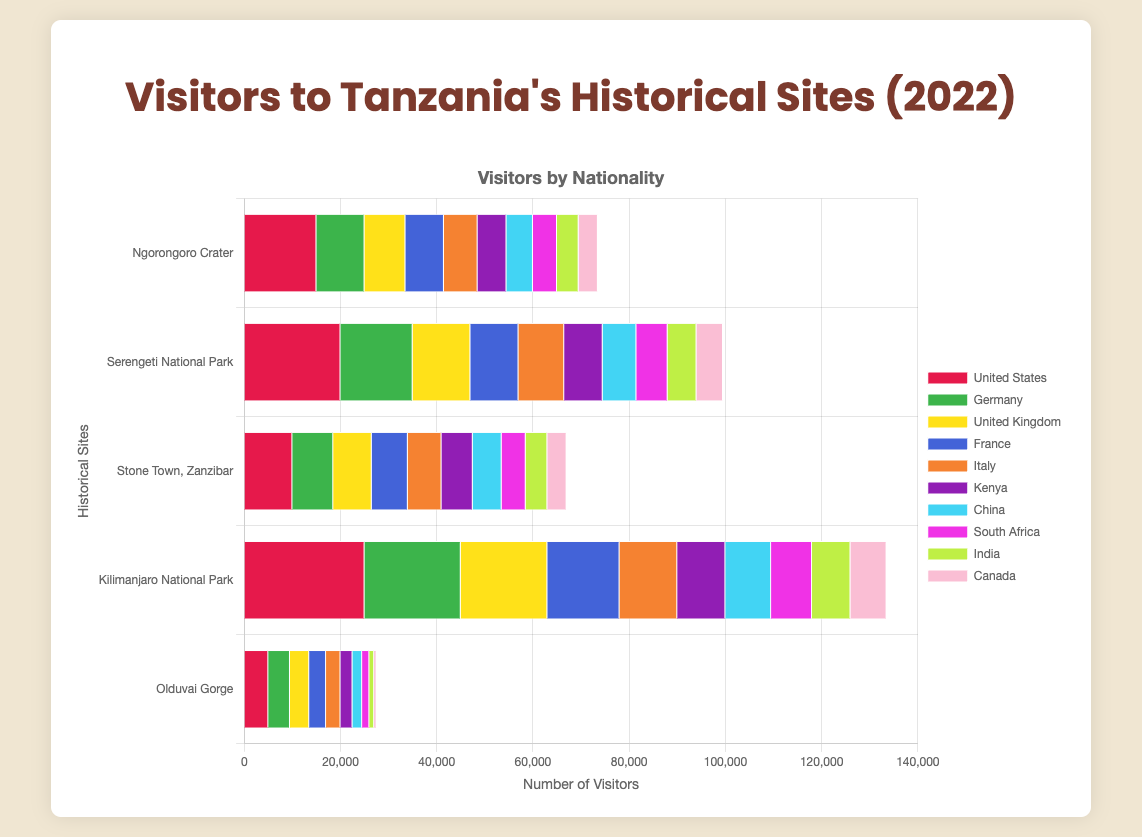Which historical site received the most visitors from the United States? Among all the historical sites, Kilimanjaro National Park has the highest number of visitors from the United States at 25,000.
Answer: Kilimanjaro National Park How many total visitors did Ngorongoro Crater receive from Germany, France, and Italy? Combine the visitors from Germany (10,000), France (8,000), and Italy (7,000) to get a total of 10,000 + 8,000 + 7,000 = 25,000 visitors.
Answer: 25,000 Which site had more visitors from China: Serengeti National Park or Stone Town, Zanzibar? Serengeti National Park had 7,000 visitors from China, while Stone Town, Zanzibar had 6,000 visitors from China. Therefore, Serengeti National Park had more visitors.
Answer: Serengeti National Park What is the difference in the number of visitors from Kenya between Kilimanjaro National Park and Olduvai Gorge? Kilimanjaro National Park had 10,000 visitors from Kenya and Olduvai Gorge had 2,500. The difference is 10,000 - 2,500 = 7,500 visitors.
Answer: 7,500 Which nationality consistently has the least number of visitors across all sites? By examining each site's visitors data, Canada consistently has the least number of visitors across all the sites, with the least being 500 visitors at Olduvai Gorge.
Answer: Canada Between Ngorongoro Crater and Stone Town, Zanzibar, which site had more visitors from the United Kingdom? Ngorongoro Crater had 8,500 visitors from the United Kingdom, whereas Stone Town, Zanzibar had 8,000 visitors from the United Kingdom. Ngorongoro Crater had more visitors.
Answer: Ngorongoro Crater How many visitors in total did Serengeti National Park receive? Add up the number of visitors from each nationality for Serengeti National Park: 20,000 (United States) + 15,000 (Germany) + 12,000 (United Kingdom) + 10,000 (France) + 9,500 (Italy) + 8,000 (Kenya) + 7,000 (China) + 6,500 (South Africa) + 6,000 (India) + 5,500 (Canada) = 99,500 visitors.
Answer: 99,500 Which site had fewer visitors from India: Ngorongoro Crater or Olduvai Gorge? Ngorongoro Crater had 4,500 visitors from India, whereas Olduvai Gorge had 1,000 visitors from India. Therefore, Olduvai Gorge had fewer visitors.
Answer: Olduvai Gorge Which historical site had the highest number of visitors from any single nationality, and which nationality was it? Kilimanjaro National Park had the highest number of visitors from any single nationality, with 25,000 visitors from the United States.
Answer: Kilimanjaro National Park, United States 